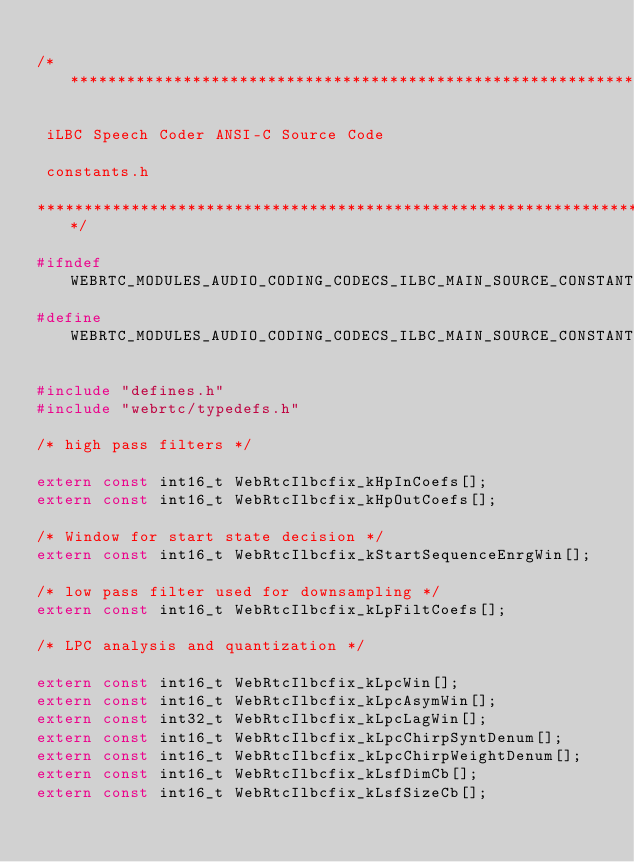<code> <loc_0><loc_0><loc_500><loc_500><_C_>
/******************************************************************

 iLBC Speech Coder ANSI-C Source Code

 constants.h

******************************************************************/

#ifndef WEBRTC_MODULES_AUDIO_CODING_CODECS_ILBC_MAIN_SOURCE_CONSTANTS_H_
#define WEBRTC_MODULES_AUDIO_CODING_CODECS_ILBC_MAIN_SOURCE_CONSTANTS_H_

#include "defines.h"
#include "webrtc/typedefs.h"

/* high pass filters */

extern const int16_t WebRtcIlbcfix_kHpInCoefs[];
extern const int16_t WebRtcIlbcfix_kHpOutCoefs[];

/* Window for start state decision */
extern const int16_t WebRtcIlbcfix_kStartSequenceEnrgWin[];

/* low pass filter used for downsampling */
extern const int16_t WebRtcIlbcfix_kLpFiltCoefs[];

/* LPC analysis and quantization */

extern const int16_t WebRtcIlbcfix_kLpcWin[];
extern const int16_t WebRtcIlbcfix_kLpcAsymWin[];
extern const int32_t WebRtcIlbcfix_kLpcLagWin[];
extern const int16_t WebRtcIlbcfix_kLpcChirpSyntDenum[];
extern const int16_t WebRtcIlbcfix_kLpcChirpWeightDenum[];
extern const int16_t WebRtcIlbcfix_kLsfDimCb[];
extern const int16_t WebRtcIlbcfix_kLsfSizeCb[];</code> 